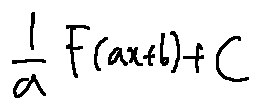<formula> <loc_0><loc_0><loc_500><loc_500>\frac { 1 } { a } F ( a x + b ) + C</formula> 